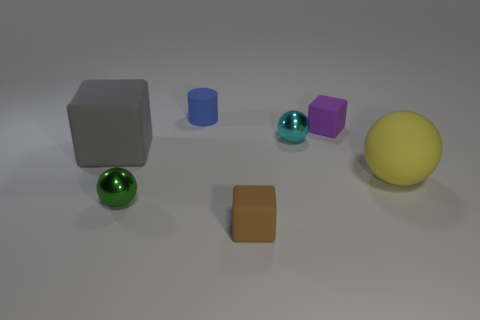Are there any tiny things on the right side of the big thing that is behind the matte sphere?
Provide a short and direct response. Yes. There is a rubber cube that is behind the tiny brown matte object and left of the purple matte cube; what is its color?
Make the answer very short. Gray. What size is the purple block?
Provide a short and direct response. Small. What number of yellow rubber things have the same size as the cyan metallic thing?
Provide a short and direct response. 0. Are the tiny ball that is behind the green sphere and the big thing that is left of the yellow thing made of the same material?
Provide a succinct answer. No. What material is the ball that is on the left side of the brown object in front of the tiny green object?
Give a very brief answer. Metal. What is the small block behind the yellow matte ball made of?
Provide a short and direct response. Rubber. How many tiny cyan objects have the same shape as the tiny green object?
Keep it short and to the point. 1. Is the color of the cylinder the same as the large matte block?
Provide a short and direct response. No. There is a small ball that is left of the tiny rubber thing that is in front of the tiny rubber block right of the tiny brown matte thing; what is its material?
Give a very brief answer. Metal. 